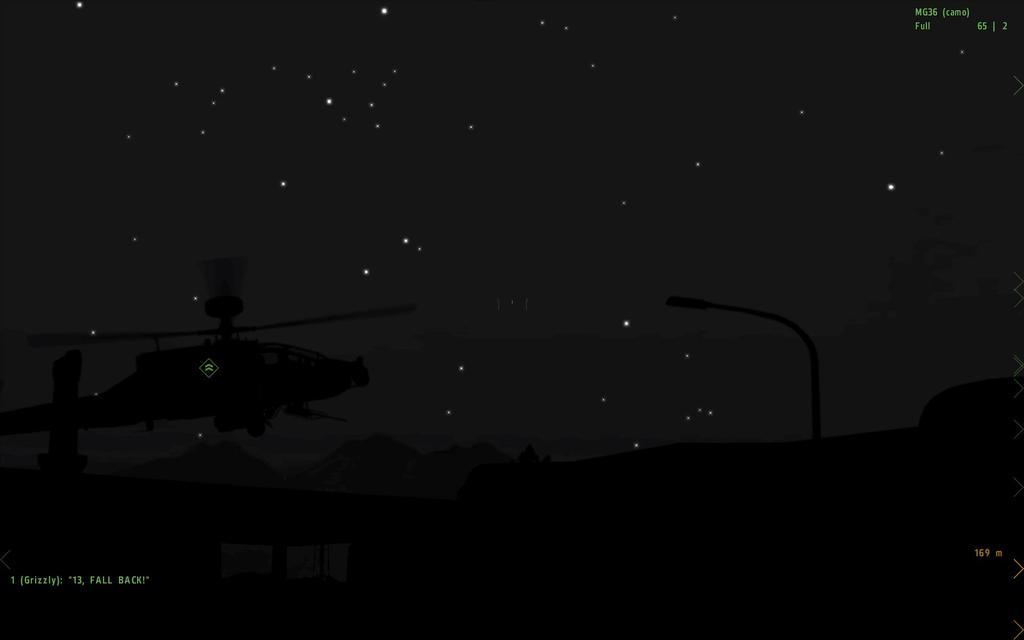What is the main subject of the image? The main subject of the image is a helicopter. What type of natural formation can be seen in the background? There are mountains in the image. What are the tall, thin structures visible in the image? Light poles are visible in the image. Is there any text present in the image? Yes, there is text present on the screen. What type of pets can be seen playing with the helicopter in the image? There are no pets present in the image, and the helicopter is not being played with. What type of calculator is visible on the helicopter in the image? There is no calculator visible on the helicopter in the image. 